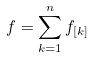Convert formula to latex. <formula><loc_0><loc_0><loc_500><loc_500>f = \sum _ { k = 1 } ^ { n } f _ { [ k ] }</formula> 